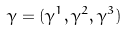Convert formula to latex. <formula><loc_0><loc_0><loc_500><loc_500>\gamma = ( \gamma ^ { 1 } , \gamma ^ { 2 } , \gamma ^ { 3 } )</formula> 